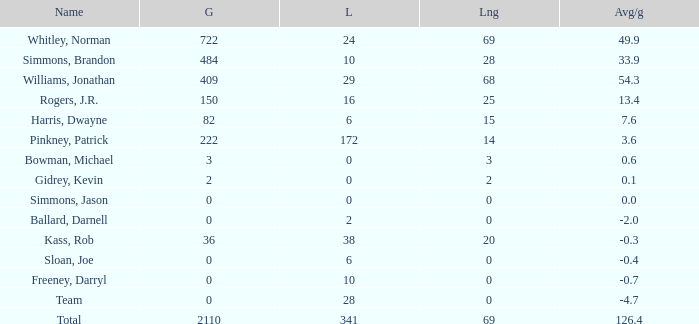What is the lowest Loss, when Long is less than 0? None. 